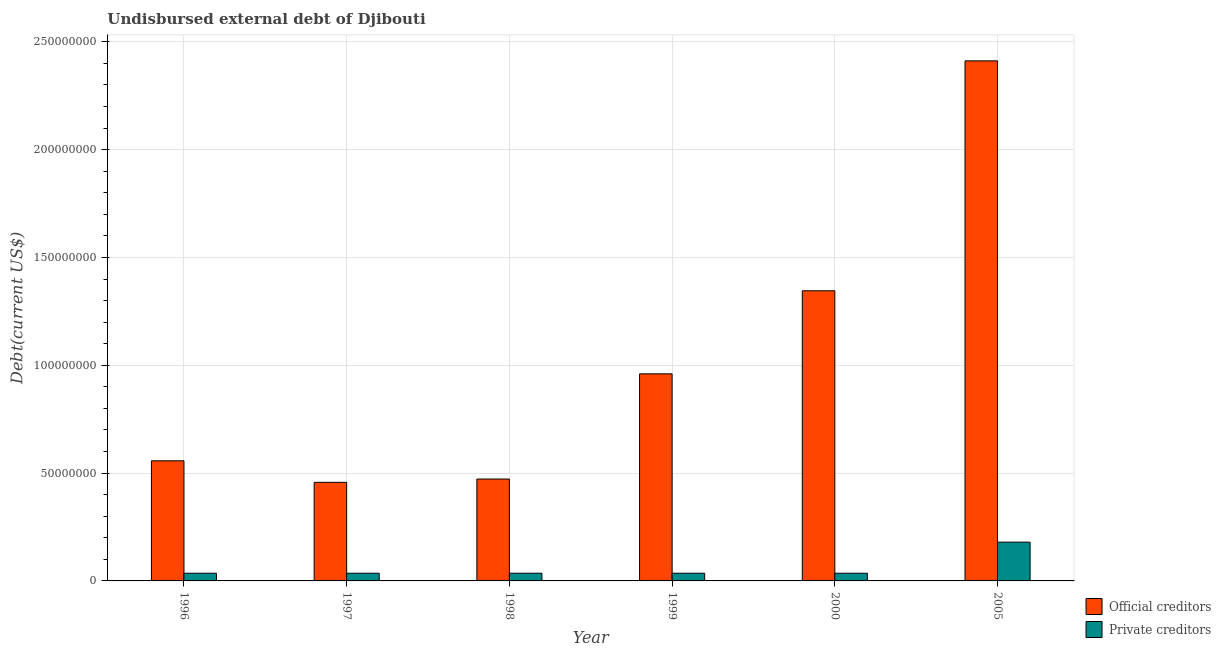How many different coloured bars are there?
Ensure brevity in your answer.  2. Are the number of bars per tick equal to the number of legend labels?
Your answer should be compact. Yes. Are the number of bars on each tick of the X-axis equal?
Ensure brevity in your answer.  Yes. How many bars are there on the 1st tick from the left?
Offer a terse response. 2. How many bars are there on the 3rd tick from the right?
Offer a very short reply. 2. What is the label of the 2nd group of bars from the left?
Offer a terse response. 1997. In how many cases, is the number of bars for a given year not equal to the number of legend labels?
Your response must be concise. 0. What is the undisbursed external debt of official creditors in 2000?
Your answer should be very brief. 1.35e+08. Across all years, what is the maximum undisbursed external debt of private creditors?
Your response must be concise. 1.80e+07. Across all years, what is the minimum undisbursed external debt of official creditors?
Give a very brief answer. 4.57e+07. What is the total undisbursed external debt of private creditors in the graph?
Make the answer very short. 3.58e+07. What is the difference between the undisbursed external debt of official creditors in 1999 and that in 2005?
Make the answer very short. -1.45e+08. What is the difference between the undisbursed external debt of private creditors in 1999 and the undisbursed external debt of official creditors in 2000?
Your answer should be compact. 0. What is the average undisbursed external debt of private creditors per year?
Offer a terse response. 5.97e+06. Is the undisbursed external debt of official creditors in 1999 less than that in 2000?
Keep it short and to the point. Yes. What is the difference between the highest and the second highest undisbursed external debt of private creditors?
Provide a succinct answer. 1.44e+07. What is the difference between the highest and the lowest undisbursed external debt of private creditors?
Your response must be concise. 1.44e+07. In how many years, is the undisbursed external debt of official creditors greater than the average undisbursed external debt of official creditors taken over all years?
Offer a terse response. 2. Is the sum of the undisbursed external debt of private creditors in 1996 and 1998 greater than the maximum undisbursed external debt of official creditors across all years?
Make the answer very short. No. What does the 2nd bar from the left in 1997 represents?
Ensure brevity in your answer.  Private creditors. What does the 2nd bar from the right in 1998 represents?
Your answer should be very brief. Official creditors. How many bars are there?
Provide a short and direct response. 12. Are all the bars in the graph horizontal?
Provide a succinct answer. No. What is the difference between two consecutive major ticks on the Y-axis?
Make the answer very short. 5.00e+07. What is the title of the graph?
Provide a succinct answer. Undisbursed external debt of Djibouti. Does "Agricultural land" appear as one of the legend labels in the graph?
Make the answer very short. No. What is the label or title of the X-axis?
Your answer should be very brief. Year. What is the label or title of the Y-axis?
Keep it short and to the point. Debt(current US$). What is the Debt(current US$) of Official creditors in 1996?
Offer a very short reply. 5.57e+07. What is the Debt(current US$) of Private creditors in 1996?
Offer a terse response. 3.57e+06. What is the Debt(current US$) in Official creditors in 1997?
Provide a short and direct response. 4.57e+07. What is the Debt(current US$) in Private creditors in 1997?
Offer a very short reply. 3.57e+06. What is the Debt(current US$) in Official creditors in 1998?
Provide a short and direct response. 4.72e+07. What is the Debt(current US$) of Private creditors in 1998?
Offer a terse response. 3.57e+06. What is the Debt(current US$) of Official creditors in 1999?
Your answer should be compact. 9.60e+07. What is the Debt(current US$) in Private creditors in 1999?
Give a very brief answer. 3.57e+06. What is the Debt(current US$) of Official creditors in 2000?
Your answer should be very brief. 1.35e+08. What is the Debt(current US$) in Private creditors in 2000?
Your answer should be compact. 3.57e+06. What is the Debt(current US$) in Official creditors in 2005?
Your response must be concise. 2.41e+08. What is the Debt(current US$) of Private creditors in 2005?
Your answer should be compact. 1.80e+07. Across all years, what is the maximum Debt(current US$) of Official creditors?
Your answer should be very brief. 2.41e+08. Across all years, what is the maximum Debt(current US$) of Private creditors?
Ensure brevity in your answer.  1.80e+07. Across all years, what is the minimum Debt(current US$) in Official creditors?
Provide a short and direct response. 4.57e+07. Across all years, what is the minimum Debt(current US$) of Private creditors?
Give a very brief answer. 3.57e+06. What is the total Debt(current US$) in Official creditors in the graph?
Your response must be concise. 6.20e+08. What is the total Debt(current US$) in Private creditors in the graph?
Offer a very short reply. 3.58e+07. What is the difference between the Debt(current US$) in Official creditors in 1996 and that in 1997?
Your answer should be very brief. 9.99e+06. What is the difference between the Debt(current US$) in Private creditors in 1996 and that in 1997?
Your answer should be very brief. 0. What is the difference between the Debt(current US$) in Official creditors in 1996 and that in 1998?
Keep it short and to the point. 8.46e+06. What is the difference between the Debt(current US$) in Private creditors in 1996 and that in 1998?
Give a very brief answer. 0. What is the difference between the Debt(current US$) in Official creditors in 1996 and that in 1999?
Your response must be concise. -4.03e+07. What is the difference between the Debt(current US$) in Private creditors in 1996 and that in 1999?
Your answer should be very brief. 0. What is the difference between the Debt(current US$) of Official creditors in 1996 and that in 2000?
Ensure brevity in your answer.  -7.89e+07. What is the difference between the Debt(current US$) in Private creditors in 1996 and that in 2000?
Your answer should be compact. 0. What is the difference between the Debt(current US$) of Official creditors in 1996 and that in 2005?
Keep it short and to the point. -1.85e+08. What is the difference between the Debt(current US$) of Private creditors in 1996 and that in 2005?
Give a very brief answer. -1.44e+07. What is the difference between the Debt(current US$) in Official creditors in 1997 and that in 1998?
Keep it short and to the point. -1.53e+06. What is the difference between the Debt(current US$) of Official creditors in 1997 and that in 1999?
Your answer should be very brief. -5.03e+07. What is the difference between the Debt(current US$) of Private creditors in 1997 and that in 1999?
Provide a short and direct response. 0. What is the difference between the Debt(current US$) in Official creditors in 1997 and that in 2000?
Offer a terse response. -8.88e+07. What is the difference between the Debt(current US$) in Official creditors in 1997 and that in 2005?
Your response must be concise. -1.95e+08. What is the difference between the Debt(current US$) of Private creditors in 1997 and that in 2005?
Ensure brevity in your answer.  -1.44e+07. What is the difference between the Debt(current US$) in Official creditors in 1998 and that in 1999?
Provide a short and direct response. -4.88e+07. What is the difference between the Debt(current US$) of Official creditors in 1998 and that in 2000?
Make the answer very short. -8.73e+07. What is the difference between the Debt(current US$) of Official creditors in 1998 and that in 2005?
Your answer should be compact. -1.94e+08. What is the difference between the Debt(current US$) of Private creditors in 1998 and that in 2005?
Your answer should be very brief. -1.44e+07. What is the difference between the Debt(current US$) in Official creditors in 1999 and that in 2000?
Provide a short and direct response. -3.85e+07. What is the difference between the Debt(current US$) in Private creditors in 1999 and that in 2000?
Make the answer very short. 0. What is the difference between the Debt(current US$) in Official creditors in 1999 and that in 2005?
Your answer should be compact. -1.45e+08. What is the difference between the Debt(current US$) of Private creditors in 1999 and that in 2005?
Ensure brevity in your answer.  -1.44e+07. What is the difference between the Debt(current US$) of Official creditors in 2000 and that in 2005?
Give a very brief answer. -1.07e+08. What is the difference between the Debt(current US$) of Private creditors in 2000 and that in 2005?
Keep it short and to the point. -1.44e+07. What is the difference between the Debt(current US$) in Official creditors in 1996 and the Debt(current US$) in Private creditors in 1997?
Offer a very short reply. 5.21e+07. What is the difference between the Debt(current US$) in Official creditors in 1996 and the Debt(current US$) in Private creditors in 1998?
Your answer should be very brief. 5.21e+07. What is the difference between the Debt(current US$) of Official creditors in 1996 and the Debt(current US$) of Private creditors in 1999?
Ensure brevity in your answer.  5.21e+07. What is the difference between the Debt(current US$) of Official creditors in 1996 and the Debt(current US$) of Private creditors in 2000?
Make the answer very short. 5.21e+07. What is the difference between the Debt(current US$) in Official creditors in 1996 and the Debt(current US$) in Private creditors in 2005?
Make the answer very short. 3.77e+07. What is the difference between the Debt(current US$) of Official creditors in 1997 and the Debt(current US$) of Private creditors in 1998?
Your answer should be very brief. 4.21e+07. What is the difference between the Debt(current US$) of Official creditors in 1997 and the Debt(current US$) of Private creditors in 1999?
Provide a short and direct response. 4.21e+07. What is the difference between the Debt(current US$) of Official creditors in 1997 and the Debt(current US$) of Private creditors in 2000?
Offer a terse response. 4.21e+07. What is the difference between the Debt(current US$) of Official creditors in 1997 and the Debt(current US$) of Private creditors in 2005?
Your answer should be very brief. 2.77e+07. What is the difference between the Debt(current US$) in Official creditors in 1998 and the Debt(current US$) in Private creditors in 1999?
Make the answer very short. 4.37e+07. What is the difference between the Debt(current US$) of Official creditors in 1998 and the Debt(current US$) of Private creditors in 2000?
Keep it short and to the point. 4.37e+07. What is the difference between the Debt(current US$) of Official creditors in 1998 and the Debt(current US$) of Private creditors in 2005?
Provide a short and direct response. 2.93e+07. What is the difference between the Debt(current US$) of Official creditors in 1999 and the Debt(current US$) of Private creditors in 2000?
Keep it short and to the point. 9.25e+07. What is the difference between the Debt(current US$) of Official creditors in 1999 and the Debt(current US$) of Private creditors in 2005?
Provide a short and direct response. 7.81e+07. What is the difference between the Debt(current US$) of Official creditors in 2000 and the Debt(current US$) of Private creditors in 2005?
Your answer should be very brief. 1.17e+08. What is the average Debt(current US$) of Official creditors per year?
Your answer should be compact. 1.03e+08. What is the average Debt(current US$) in Private creditors per year?
Your answer should be very brief. 5.97e+06. In the year 1996, what is the difference between the Debt(current US$) in Official creditors and Debt(current US$) in Private creditors?
Make the answer very short. 5.21e+07. In the year 1997, what is the difference between the Debt(current US$) of Official creditors and Debt(current US$) of Private creditors?
Offer a very short reply. 4.21e+07. In the year 1998, what is the difference between the Debt(current US$) in Official creditors and Debt(current US$) in Private creditors?
Your response must be concise. 4.37e+07. In the year 1999, what is the difference between the Debt(current US$) in Official creditors and Debt(current US$) in Private creditors?
Provide a succinct answer. 9.25e+07. In the year 2000, what is the difference between the Debt(current US$) of Official creditors and Debt(current US$) of Private creditors?
Provide a short and direct response. 1.31e+08. In the year 2005, what is the difference between the Debt(current US$) of Official creditors and Debt(current US$) of Private creditors?
Give a very brief answer. 2.23e+08. What is the ratio of the Debt(current US$) in Official creditors in 1996 to that in 1997?
Provide a short and direct response. 1.22. What is the ratio of the Debt(current US$) in Official creditors in 1996 to that in 1998?
Your answer should be very brief. 1.18. What is the ratio of the Debt(current US$) in Official creditors in 1996 to that in 1999?
Your answer should be very brief. 0.58. What is the ratio of the Debt(current US$) in Private creditors in 1996 to that in 1999?
Offer a terse response. 1. What is the ratio of the Debt(current US$) of Official creditors in 1996 to that in 2000?
Keep it short and to the point. 0.41. What is the ratio of the Debt(current US$) in Official creditors in 1996 to that in 2005?
Give a very brief answer. 0.23. What is the ratio of the Debt(current US$) of Private creditors in 1996 to that in 2005?
Provide a succinct answer. 0.2. What is the ratio of the Debt(current US$) of Official creditors in 1997 to that in 1998?
Make the answer very short. 0.97. What is the ratio of the Debt(current US$) in Private creditors in 1997 to that in 1998?
Provide a succinct answer. 1. What is the ratio of the Debt(current US$) in Official creditors in 1997 to that in 1999?
Your answer should be very brief. 0.48. What is the ratio of the Debt(current US$) of Private creditors in 1997 to that in 1999?
Offer a terse response. 1. What is the ratio of the Debt(current US$) of Official creditors in 1997 to that in 2000?
Make the answer very short. 0.34. What is the ratio of the Debt(current US$) of Private creditors in 1997 to that in 2000?
Offer a very short reply. 1. What is the ratio of the Debt(current US$) in Official creditors in 1997 to that in 2005?
Your response must be concise. 0.19. What is the ratio of the Debt(current US$) of Private creditors in 1997 to that in 2005?
Provide a succinct answer. 0.2. What is the ratio of the Debt(current US$) of Official creditors in 1998 to that in 1999?
Ensure brevity in your answer.  0.49. What is the ratio of the Debt(current US$) of Official creditors in 1998 to that in 2000?
Make the answer very short. 0.35. What is the ratio of the Debt(current US$) of Official creditors in 1998 to that in 2005?
Keep it short and to the point. 0.2. What is the ratio of the Debt(current US$) in Private creditors in 1998 to that in 2005?
Make the answer very short. 0.2. What is the ratio of the Debt(current US$) of Official creditors in 1999 to that in 2000?
Your answer should be compact. 0.71. What is the ratio of the Debt(current US$) of Official creditors in 1999 to that in 2005?
Your answer should be compact. 0.4. What is the ratio of the Debt(current US$) of Private creditors in 1999 to that in 2005?
Offer a terse response. 0.2. What is the ratio of the Debt(current US$) of Official creditors in 2000 to that in 2005?
Keep it short and to the point. 0.56. What is the ratio of the Debt(current US$) of Private creditors in 2000 to that in 2005?
Provide a succinct answer. 0.2. What is the difference between the highest and the second highest Debt(current US$) of Official creditors?
Offer a terse response. 1.07e+08. What is the difference between the highest and the second highest Debt(current US$) in Private creditors?
Provide a short and direct response. 1.44e+07. What is the difference between the highest and the lowest Debt(current US$) in Official creditors?
Provide a succinct answer. 1.95e+08. What is the difference between the highest and the lowest Debt(current US$) in Private creditors?
Provide a short and direct response. 1.44e+07. 